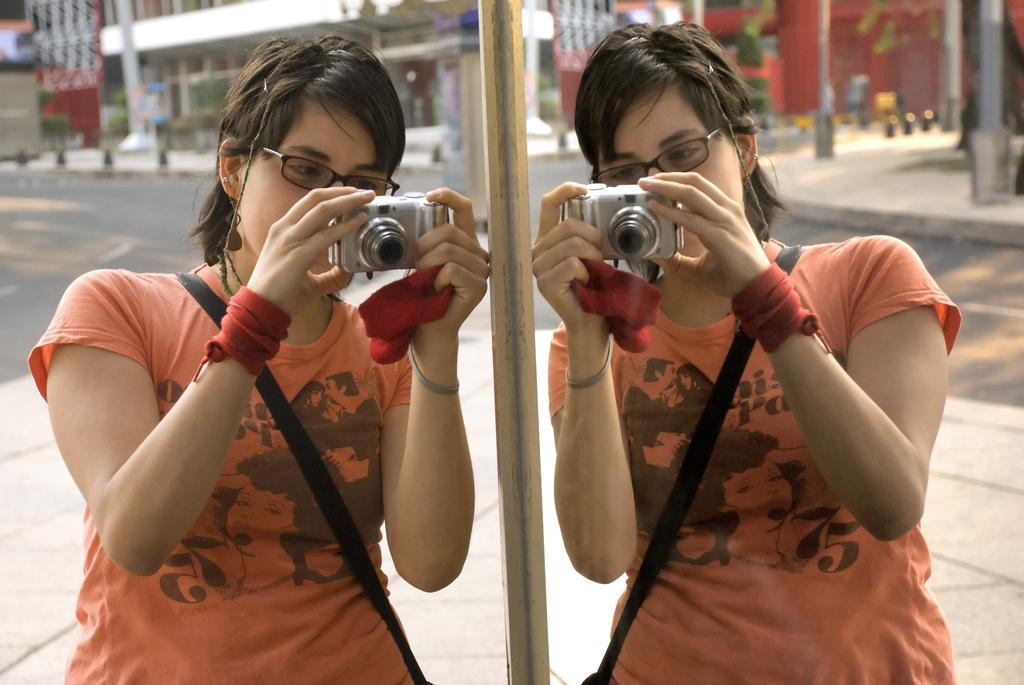Who is present in the image? There is a woman in the image. What is the woman standing beside? The woman is standing beside a mirror. What is the woman holding in the image? The woman is holding a camera. What can be seen in the mirror? The mirror reflects the woman. What can be seen in the background of the image? There are buildings visible in the image. What type of lace is draped over the pail in the image? There is no pail or lace present in the image. 